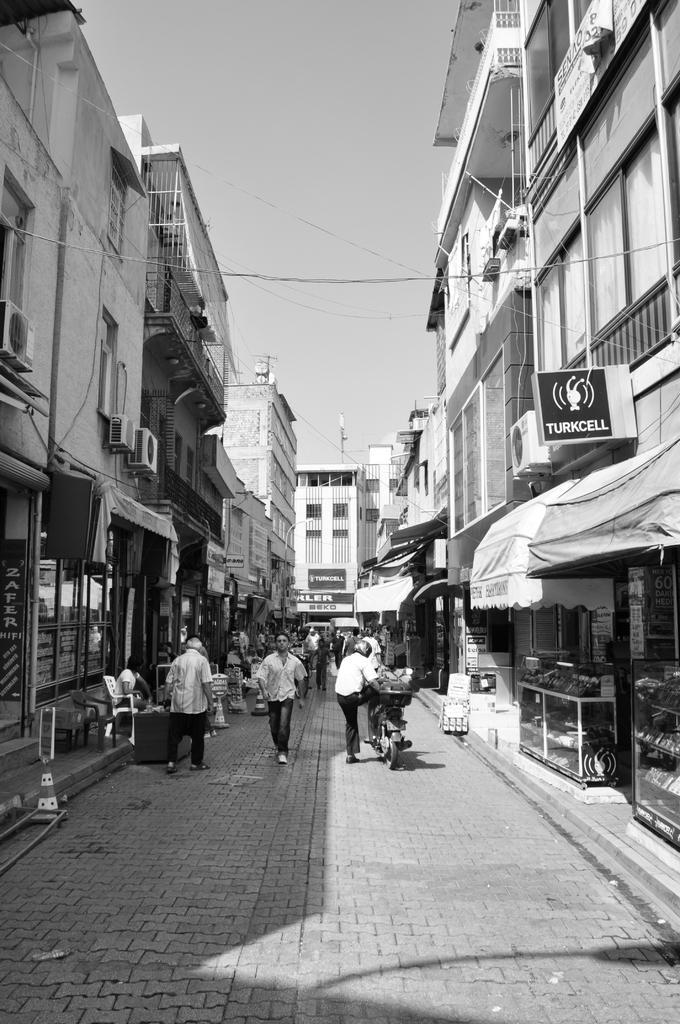Please provide a concise description of this image. In this image there are a few people walking on the streets and there is a person getting onto a bike, beside the pavement there are buildings, on the buildings there are name boards, in front of the buildings there are shops with tents, on the pavements there are chairs, counters and some other objects. 